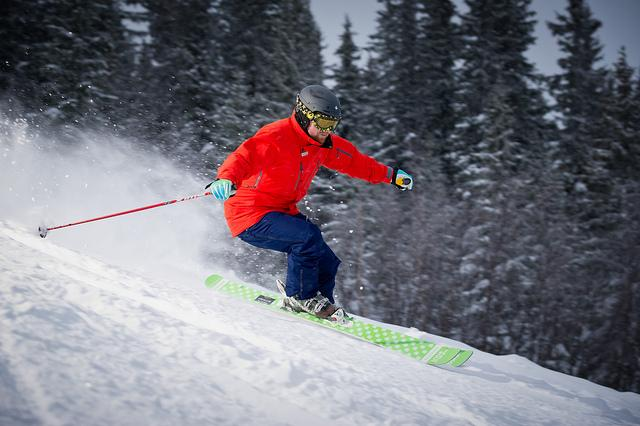What color is the snow jacket worn by the skier? red 